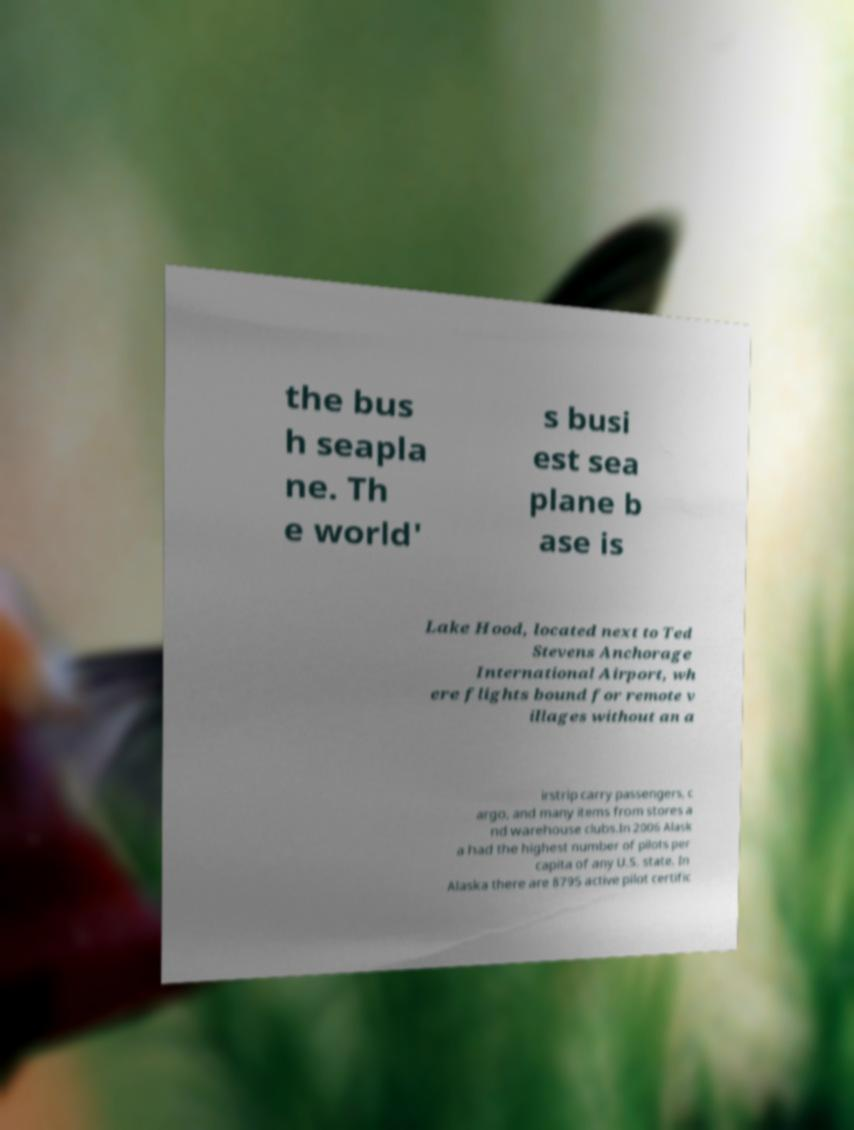Please identify and transcribe the text found in this image. the bus h seapla ne. Th e world' s busi est sea plane b ase is Lake Hood, located next to Ted Stevens Anchorage International Airport, wh ere flights bound for remote v illages without an a irstrip carry passengers, c argo, and many items from stores a nd warehouse clubs.In 2006 Alask a had the highest number of pilots per capita of any U.S. state. In Alaska there are 8795 active pilot certific 